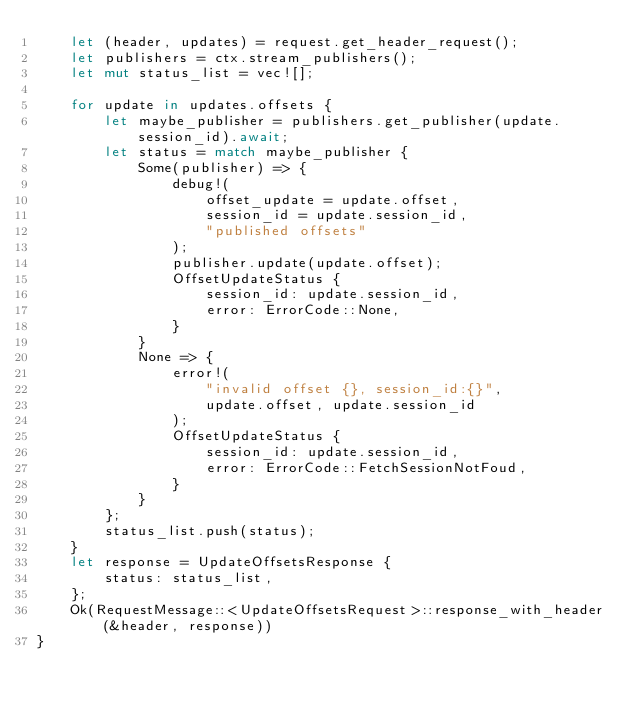<code> <loc_0><loc_0><loc_500><loc_500><_Rust_>    let (header, updates) = request.get_header_request();
    let publishers = ctx.stream_publishers();
    let mut status_list = vec![];

    for update in updates.offsets {
        let maybe_publisher = publishers.get_publisher(update.session_id).await;
        let status = match maybe_publisher {
            Some(publisher) => {
                debug!(
                    offset_update = update.offset,
                    session_id = update.session_id,
                    "published offsets"
                );
                publisher.update(update.offset);
                OffsetUpdateStatus {
                    session_id: update.session_id,
                    error: ErrorCode::None,
                }
            }
            None => {
                error!(
                    "invalid offset {}, session_id:{}",
                    update.offset, update.session_id
                );
                OffsetUpdateStatus {
                    session_id: update.session_id,
                    error: ErrorCode::FetchSessionNotFoud,
                }
            }
        };
        status_list.push(status);
    }
    let response = UpdateOffsetsResponse {
        status: status_list,
    };
    Ok(RequestMessage::<UpdateOffsetsRequest>::response_with_header(&header, response))
}
</code> 